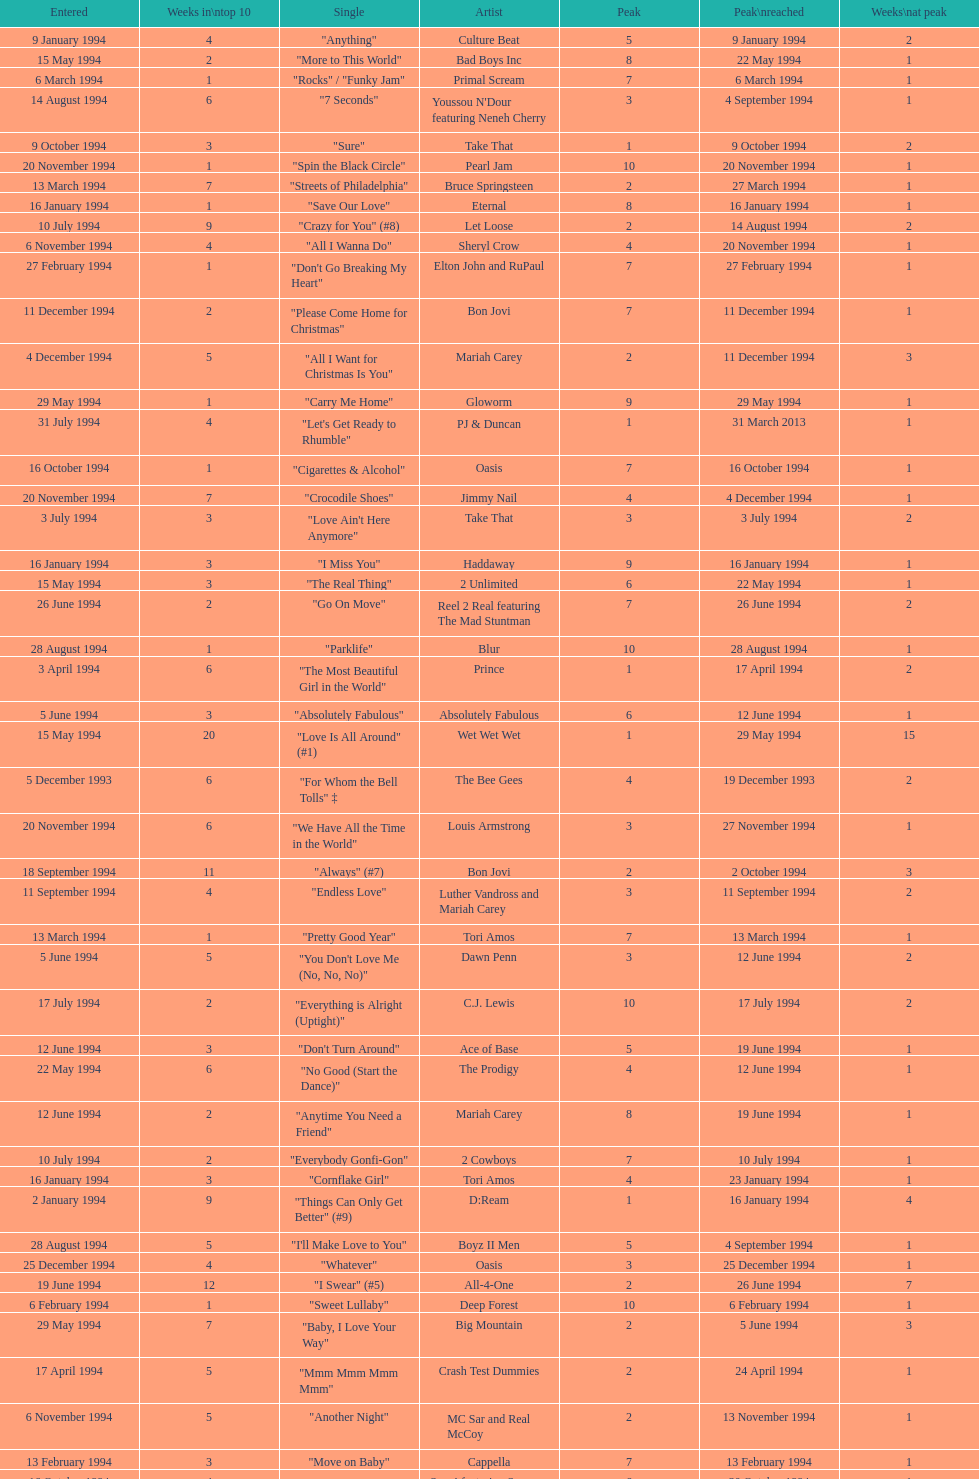Which single was the last one to be on the charts in 1993? "Come Baby Come". 